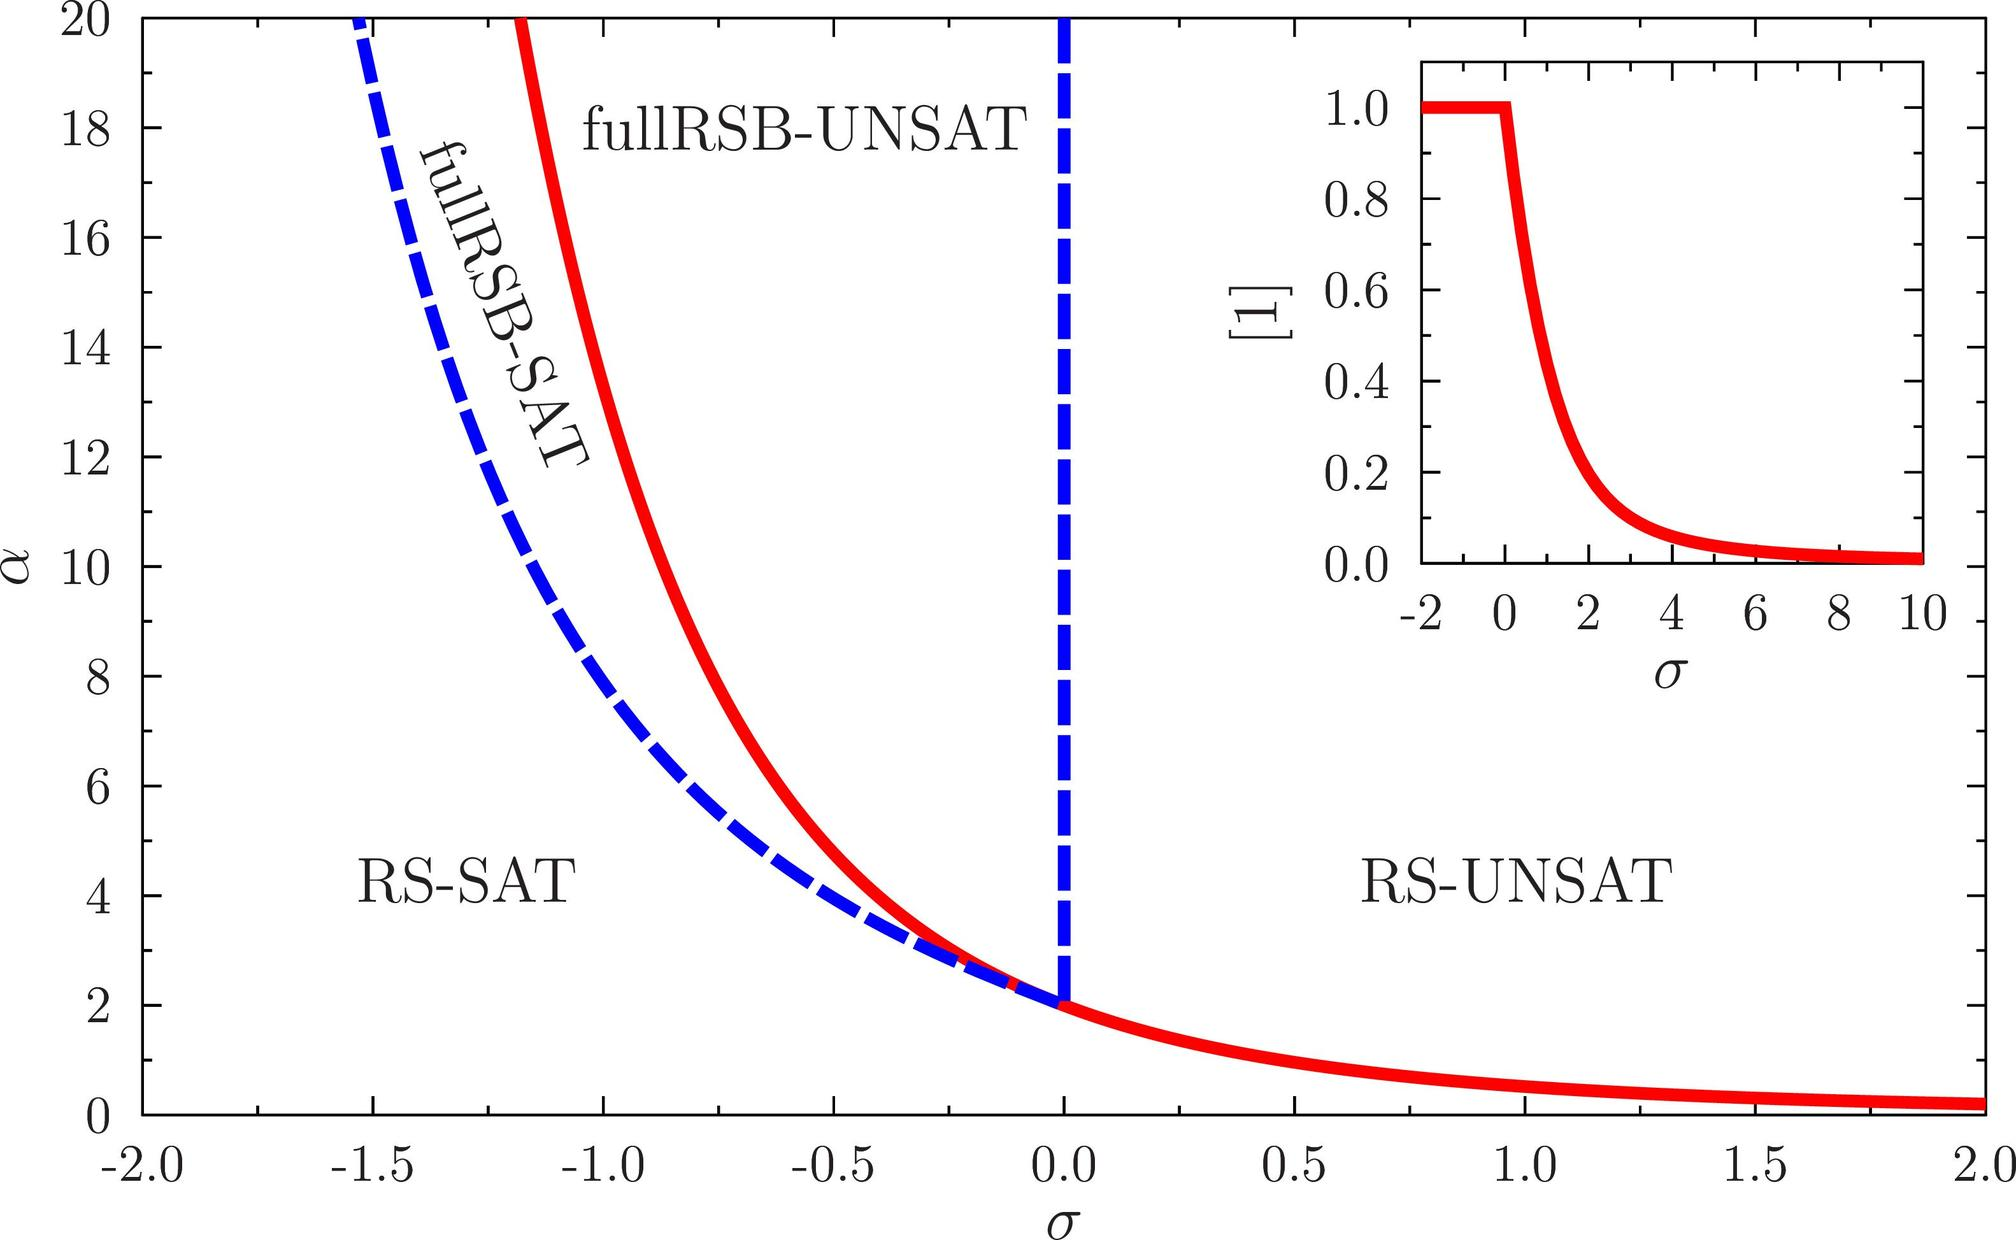Which region of the graph is associated with satisfiable conditions based on the labels provided? A. The region to the left of the blue dashed line B. The region under the red curve C. The region above the red curve D. The region to the right of the blue dashed line The labels indicate that the RS-SAT region, to the left of the blue dashed line, corresponds to satisfiable conditions, while fullRSB-UNSAT, to the right of the line, corresponds to unsatisfiable conditions. Therefore, the correct answer is A. 